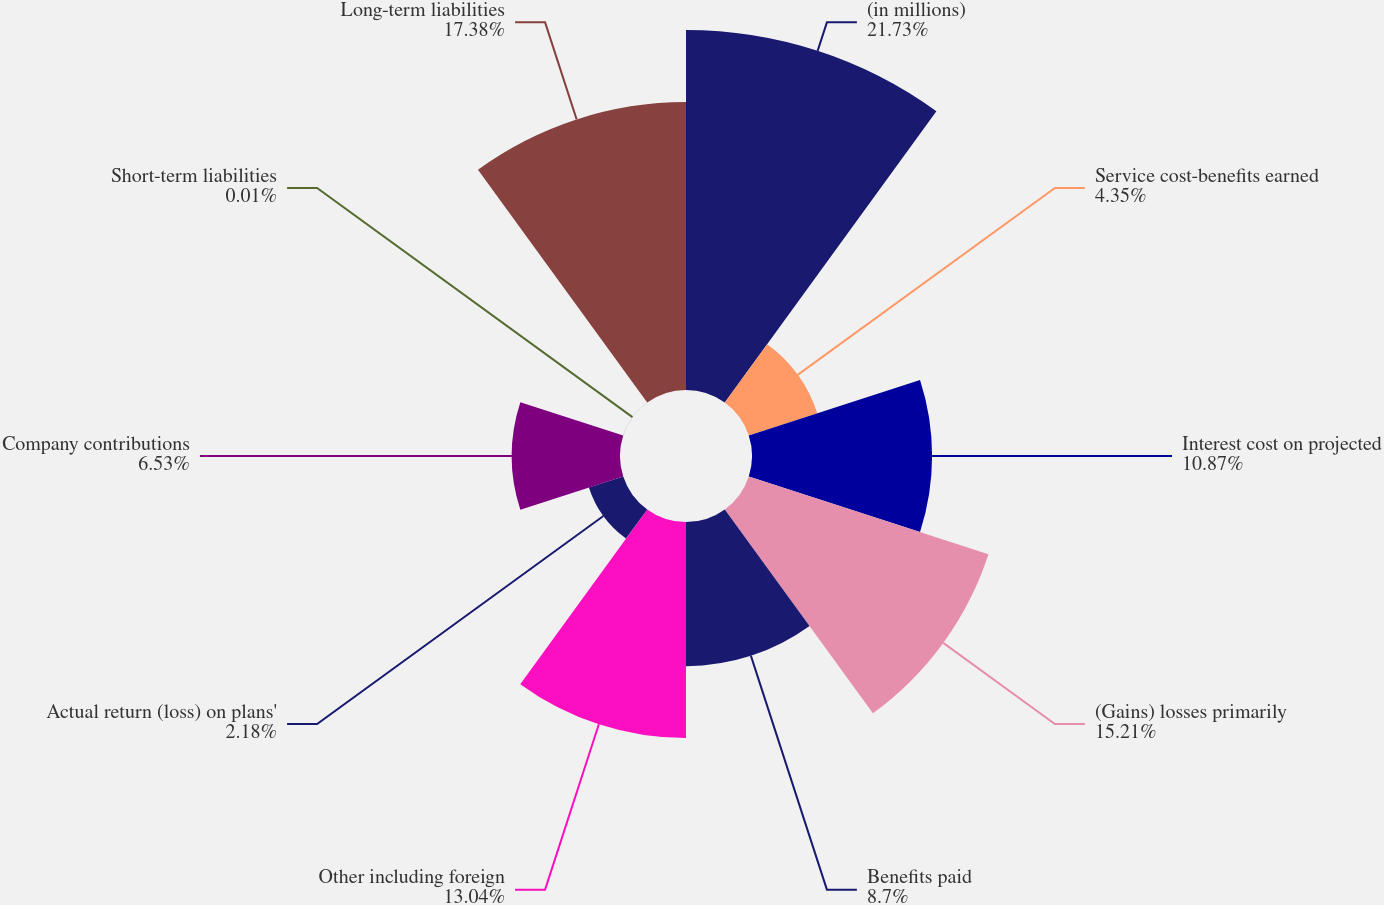<chart> <loc_0><loc_0><loc_500><loc_500><pie_chart><fcel>(in millions)<fcel>Service cost-benefits earned<fcel>Interest cost on projected<fcel>(Gains) losses primarily<fcel>Benefits paid<fcel>Other including foreign<fcel>Actual return (loss) on plans'<fcel>Company contributions<fcel>Short-term liabilities<fcel>Long-term liabilities<nl><fcel>21.73%<fcel>4.35%<fcel>10.87%<fcel>15.21%<fcel>8.7%<fcel>13.04%<fcel>2.18%<fcel>6.53%<fcel>0.01%<fcel>17.38%<nl></chart> 